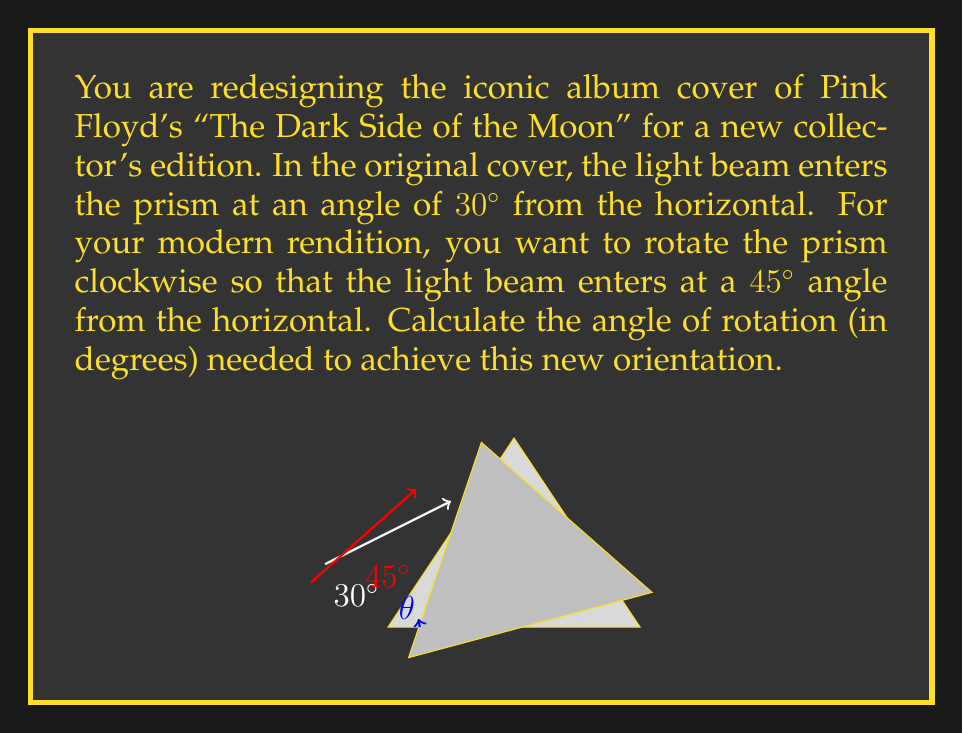Teach me how to tackle this problem. To solve this problem, we need to find the difference between the new angle and the original angle. Let's approach this step-by-step:

1) Original angle of the light beam: 30° from the horizontal
2) New desired angle of the light beam: 45° from the horizontal

The angle of rotation (θ) will be the difference between these two angles:

$$ \theta = \text{New angle} - \text{Original angle} $$

Substituting the values:

$$ \theta = 45° - 30° $$

$$ \theta = 15° $$

The positive result indicates a clockwise rotation, which matches our requirement.

To verify:
- If we rotate the prism clockwise by 15°, the light beam that was originally at 30° will now be at 45° relative to the horizontal.
- $30° + 15° = 45°$

This rotation achieves the desired new orientation for the reimagined album cover.
Answer: The required angle of rotation is $15°$ clockwise. 